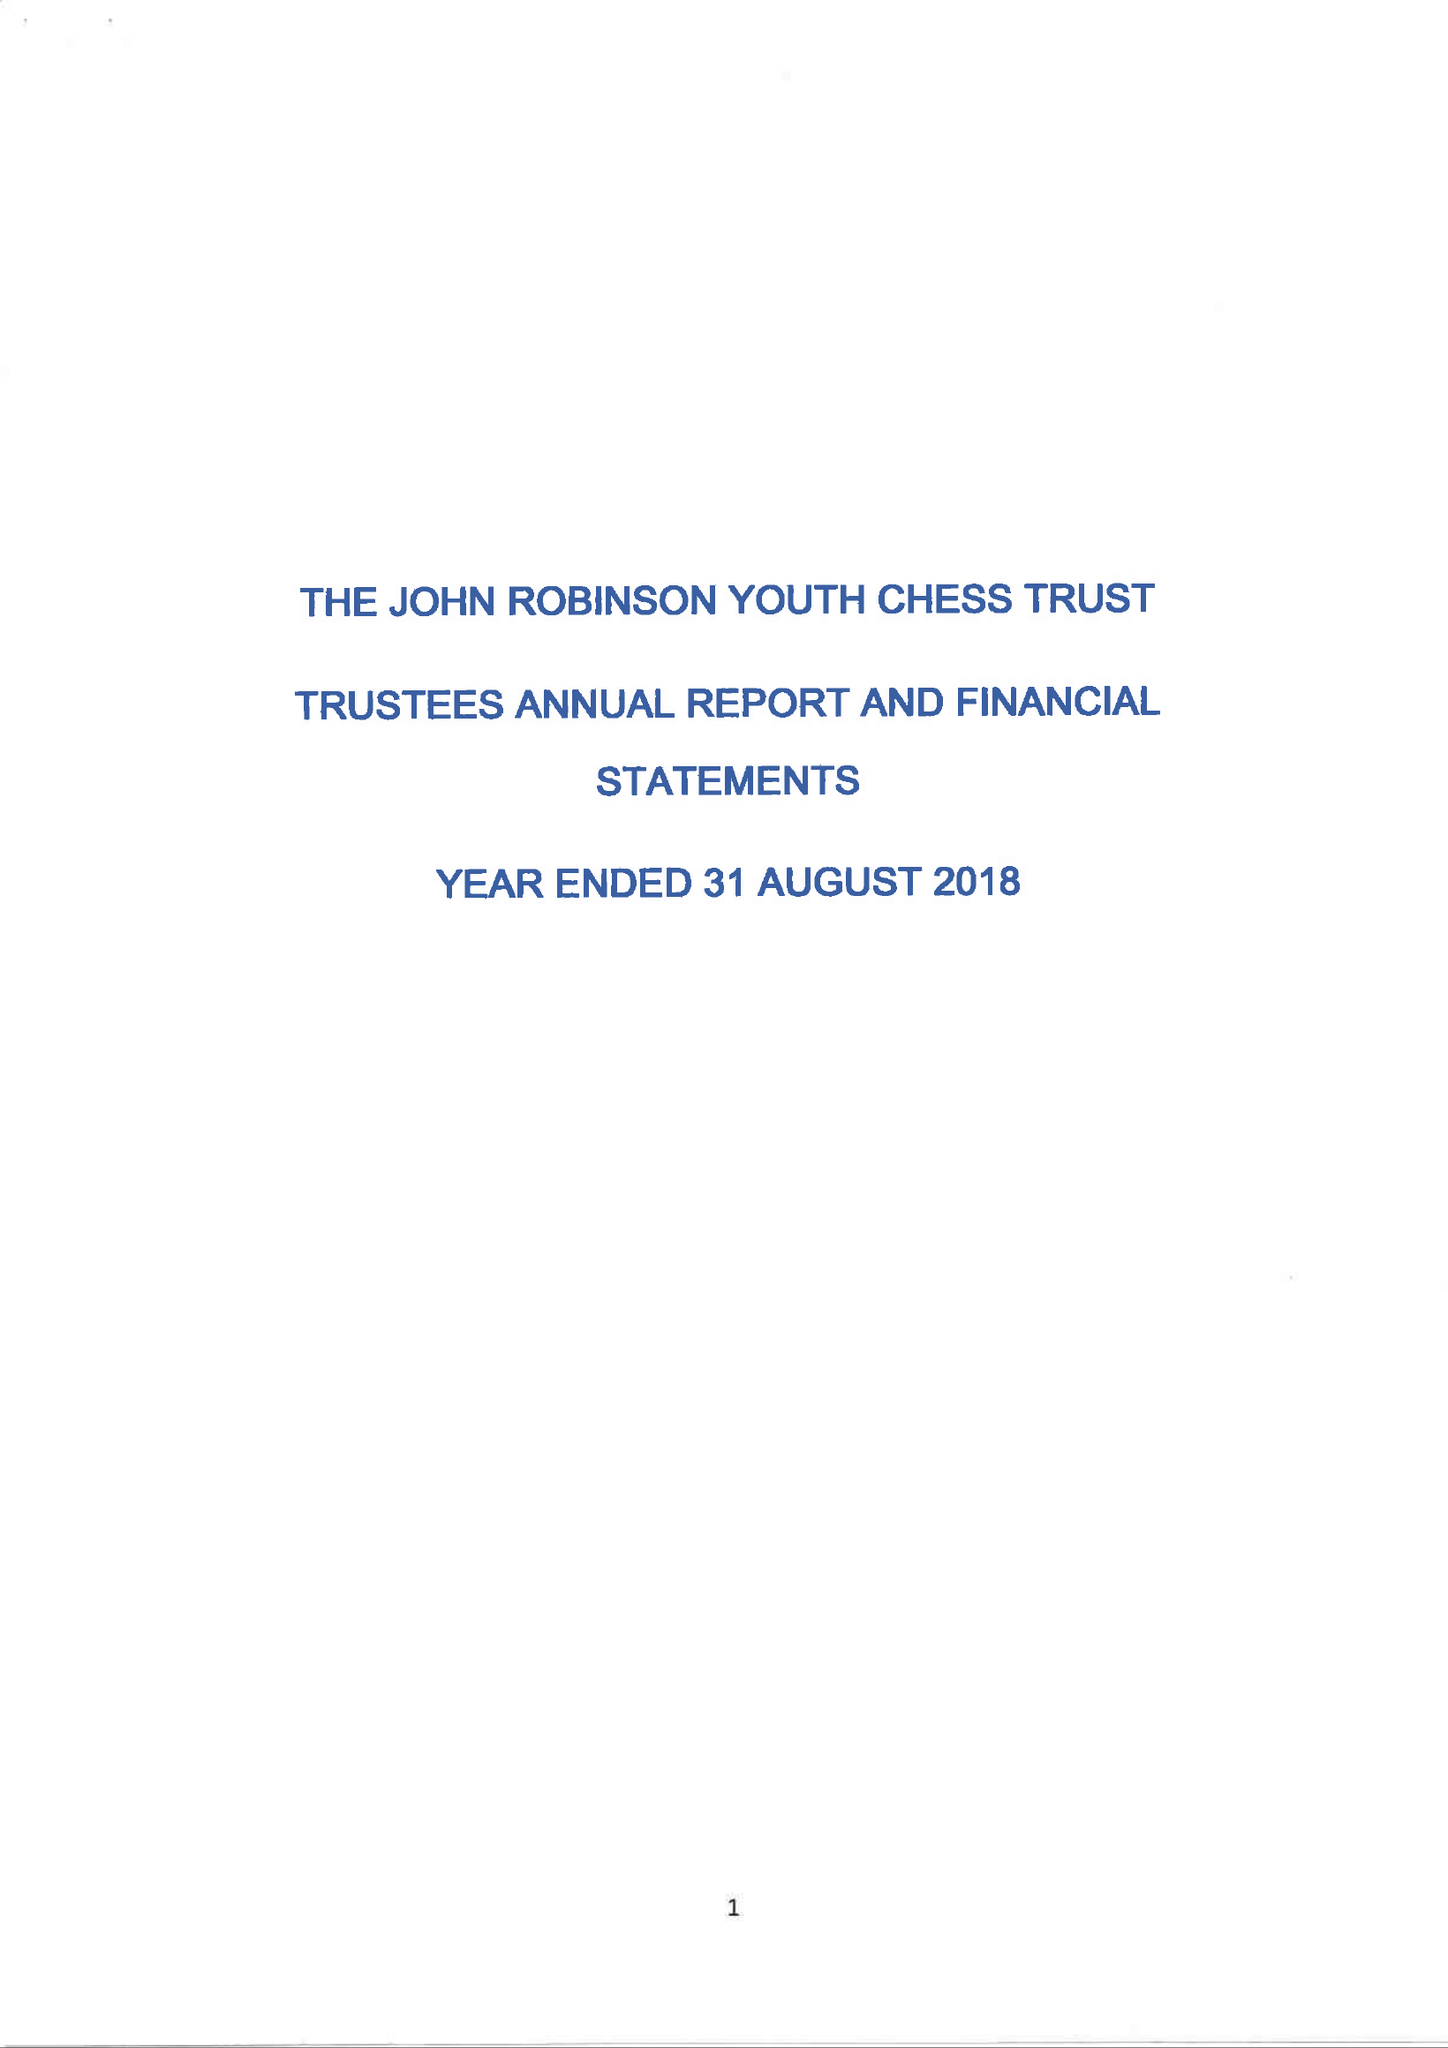What is the value for the spending_annually_in_british_pounds?
Answer the question using a single word or phrase. 32443.00 